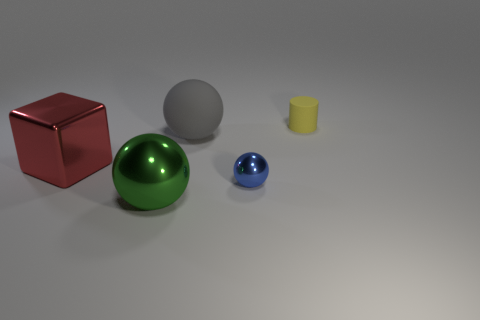Add 1 large metallic cubes. How many objects exist? 6 Subtract all large spheres. How many spheres are left? 1 Subtract all gray spheres. How many spheres are left? 2 Subtract all cylinders. How many objects are left? 4 Subtract 2 balls. How many balls are left? 1 Subtract all cyan balls. Subtract all green blocks. How many balls are left? 3 Subtract all brown cylinders. How many blue spheres are left? 1 Subtract all red matte things. Subtract all big matte spheres. How many objects are left? 4 Add 1 gray rubber spheres. How many gray rubber spheres are left? 2 Add 1 blue spheres. How many blue spheres exist? 2 